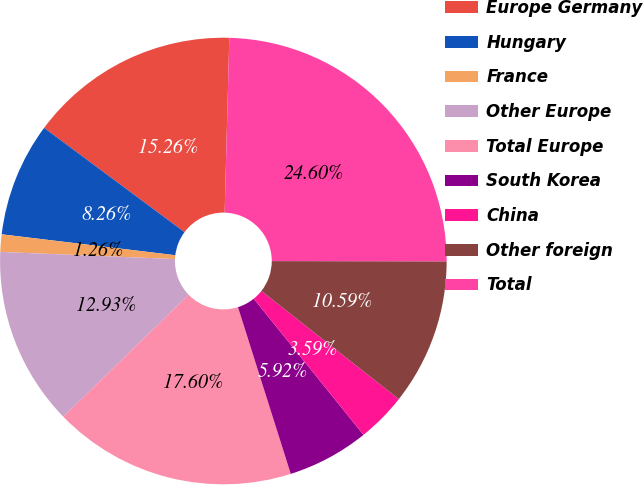Convert chart. <chart><loc_0><loc_0><loc_500><loc_500><pie_chart><fcel>Europe Germany<fcel>Hungary<fcel>France<fcel>Other Europe<fcel>Total Europe<fcel>South Korea<fcel>China<fcel>Other foreign<fcel>Total<nl><fcel>15.26%<fcel>8.26%<fcel>1.26%<fcel>12.93%<fcel>17.6%<fcel>5.92%<fcel>3.59%<fcel>10.59%<fcel>24.6%<nl></chart> 